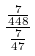<formula> <loc_0><loc_0><loc_500><loc_500>\frac { \frac { 7 } { 4 4 8 } } { \frac { 7 } { 4 7 } }</formula> 